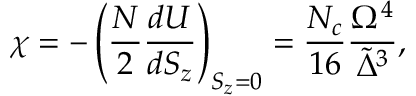Convert formula to latex. <formula><loc_0><loc_0><loc_500><loc_500>\chi = - \left ( \frac { N } { 2 } \frac { d U } { d { S _ { z } } } \right ) _ { { S _ { z } } = 0 } = \frac { { N _ { c } } } { 1 6 } \frac { \Omega ^ { 4 } } { { \tilde { \Delta } } ^ { 3 } } ,</formula> 